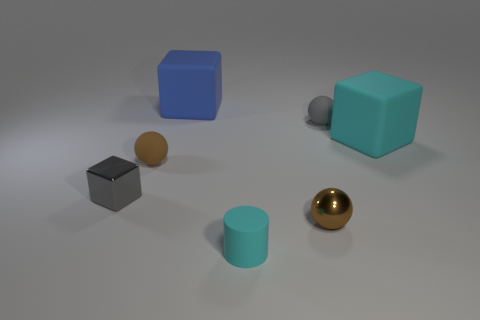Does the brown sphere behind the small gray block have the same material as the tiny brown thing that is to the right of the rubber cylinder?
Ensure brevity in your answer.  No. Are there more small spheres behind the blue block than tiny brown cylinders?
Provide a succinct answer. No. There is a metal thing that is left of the brown object in front of the small gray metal thing; what color is it?
Provide a succinct answer. Gray. There is a brown matte object that is the same size as the rubber cylinder; what is its shape?
Provide a succinct answer. Sphere. There is a small rubber thing that is the same color as the tiny shiny block; what is its shape?
Provide a succinct answer. Sphere. Are there the same number of cyan objects that are behind the gray cube and blue rubber things?
Keep it short and to the point. Yes. There is a gray thing that is in front of the small rubber thing behind the cyan rubber object that is to the right of the small brown shiny object; what is its material?
Provide a succinct answer. Metal. The brown thing that is made of the same material as the tiny gray cube is what shape?
Your response must be concise. Sphere. There is a gray object left of the matte sphere that is in front of the gray matte sphere; what number of cyan objects are left of it?
Provide a succinct answer. 0. How many cyan objects are either big rubber cubes or tiny cylinders?
Your answer should be compact. 2. 